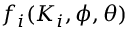Convert formula to latex. <formula><loc_0><loc_0><loc_500><loc_500>f _ { i } ( K _ { i } , \phi , \theta )</formula> 